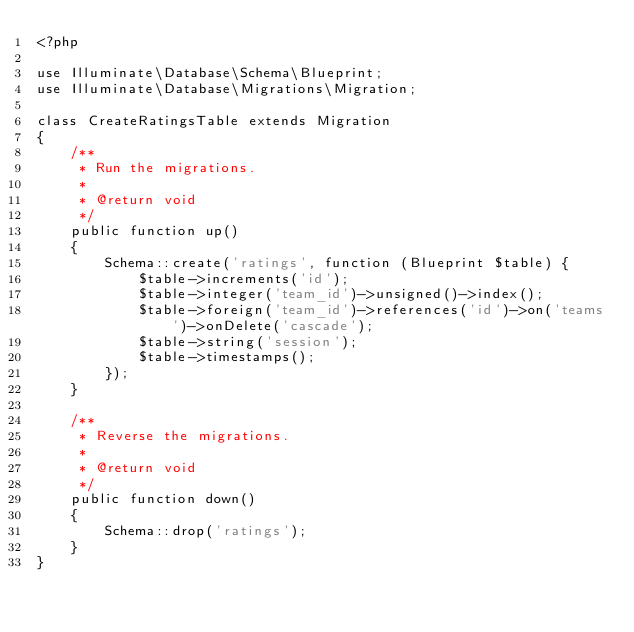Convert code to text. <code><loc_0><loc_0><loc_500><loc_500><_PHP_><?php

use Illuminate\Database\Schema\Blueprint;
use Illuminate\Database\Migrations\Migration;

class CreateRatingsTable extends Migration
{
    /**
     * Run the migrations.
     *
     * @return void
     */
    public function up()
    {
        Schema::create('ratings', function (Blueprint $table) {
            $table->increments('id');
            $table->integer('team_id')->unsigned()->index();
            $table->foreign('team_id')->references('id')->on('teams')->onDelete('cascade');
            $table->string('session');
            $table->timestamps();
        });
    }

    /**
     * Reverse the migrations.
     *
     * @return void
     */
    public function down()
    {
        Schema::drop('ratings');
    }
}</code> 